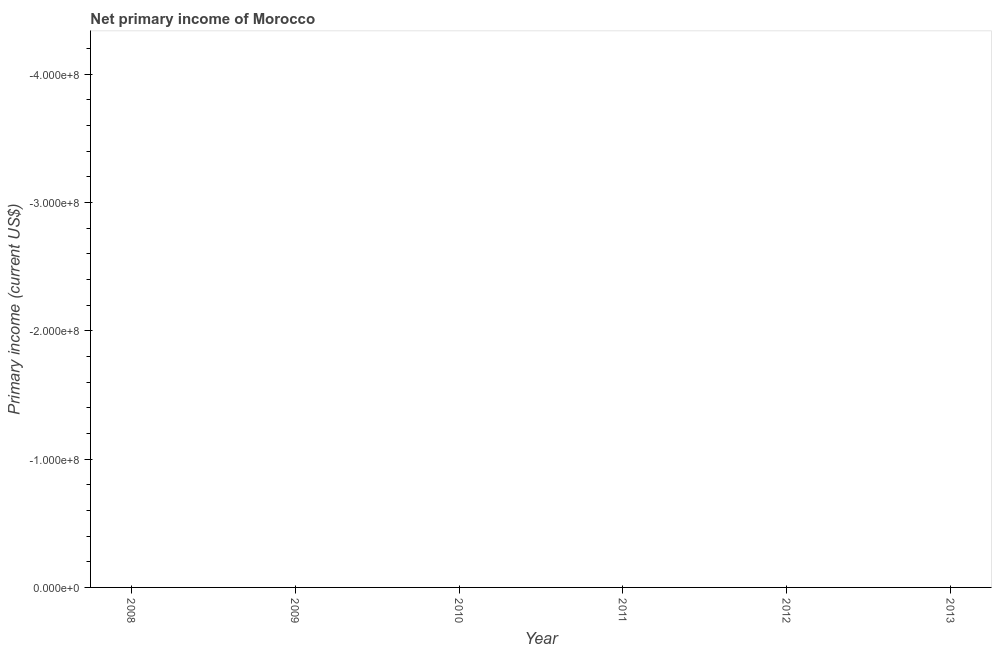What is the sum of the amount of primary income?
Make the answer very short. 0. In how many years, is the amount of primary income greater than -260000000 US$?
Your response must be concise. 0. In how many years, is the amount of primary income greater than the average amount of primary income taken over all years?
Your answer should be compact. 0. How many dotlines are there?
Keep it short and to the point. 0. How many years are there in the graph?
Your response must be concise. 6. What is the difference between two consecutive major ticks on the Y-axis?
Keep it short and to the point. 1.00e+08. What is the title of the graph?
Ensure brevity in your answer.  Net primary income of Morocco. What is the label or title of the X-axis?
Ensure brevity in your answer.  Year. What is the label or title of the Y-axis?
Your answer should be very brief. Primary income (current US$). What is the Primary income (current US$) in 2008?
Your response must be concise. 0. What is the Primary income (current US$) in 2009?
Your answer should be very brief. 0. What is the Primary income (current US$) in 2010?
Your response must be concise. 0. What is the Primary income (current US$) in 2012?
Your answer should be compact. 0. 